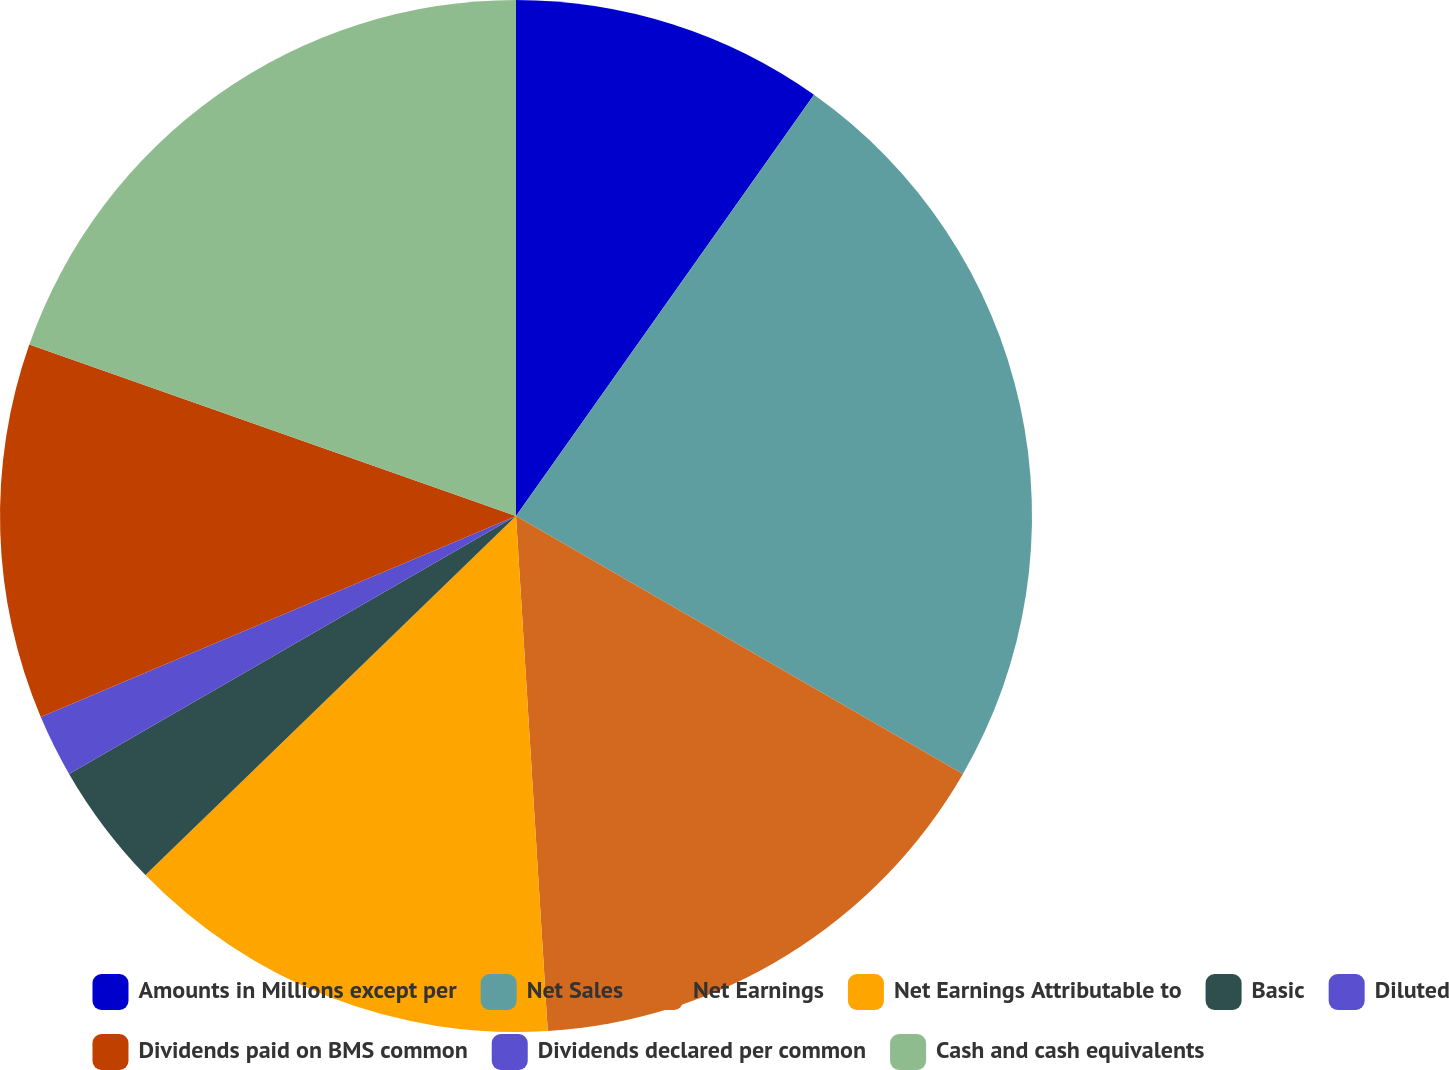Convert chart. <chart><loc_0><loc_0><loc_500><loc_500><pie_chart><fcel>Amounts in Millions except per<fcel>Net Sales<fcel>Net Earnings<fcel>Net Earnings Attributable to<fcel>Basic<fcel>Diluted<fcel>Dividends paid on BMS common<fcel>Dividends declared per common<fcel>Cash and cash equivalents<nl><fcel>9.8%<fcel>23.53%<fcel>15.69%<fcel>13.73%<fcel>3.92%<fcel>1.96%<fcel>11.76%<fcel>0.0%<fcel>19.61%<nl></chart> 